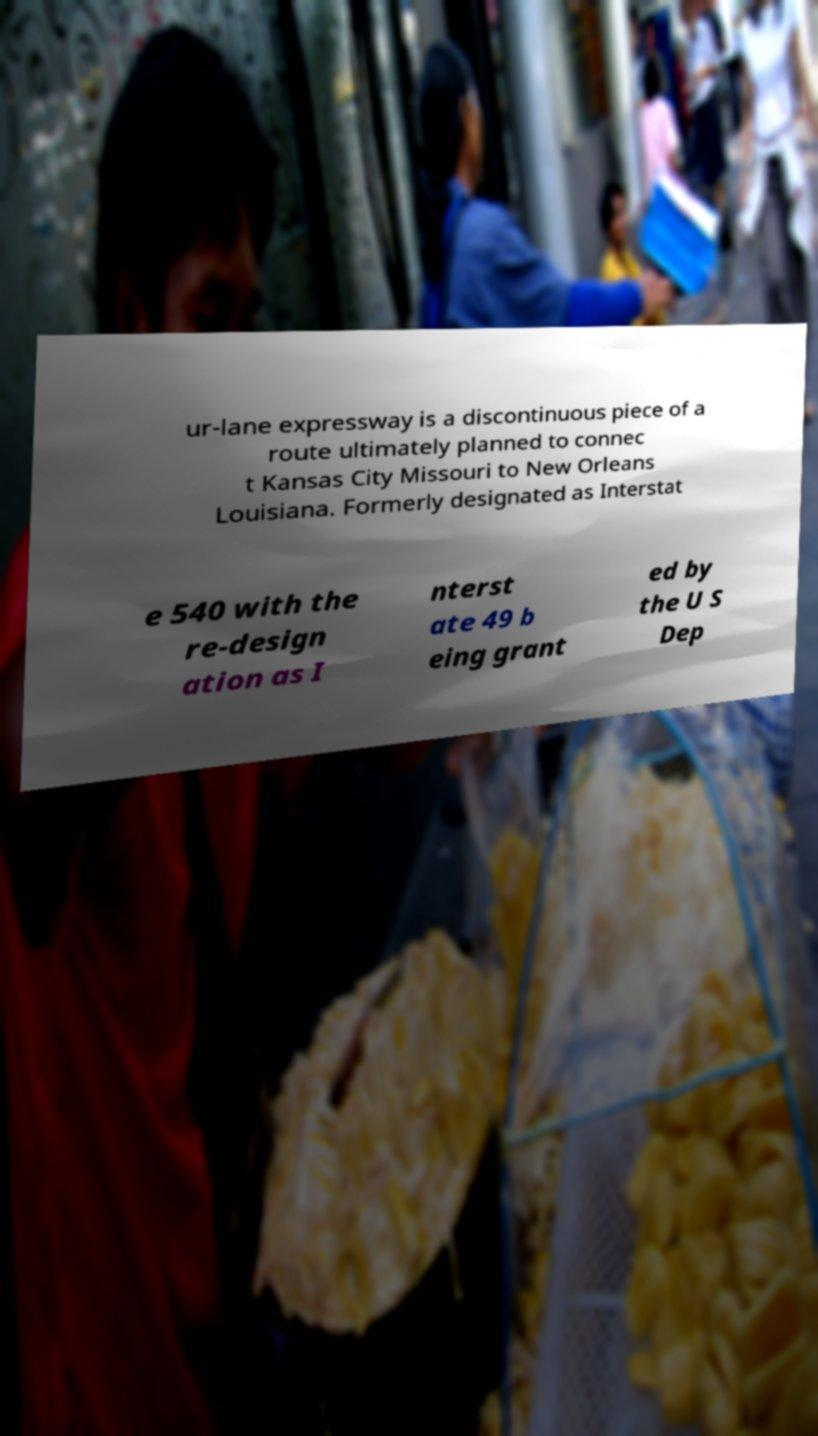Can you read and provide the text displayed in the image?This photo seems to have some interesting text. Can you extract and type it out for me? ur-lane expressway is a discontinuous piece of a route ultimately planned to connec t Kansas City Missouri to New Orleans Louisiana. Formerly designated as Interstat e 540 with the re-design ation as I nterst ate 49 b eing grant ed by the U S Dep 